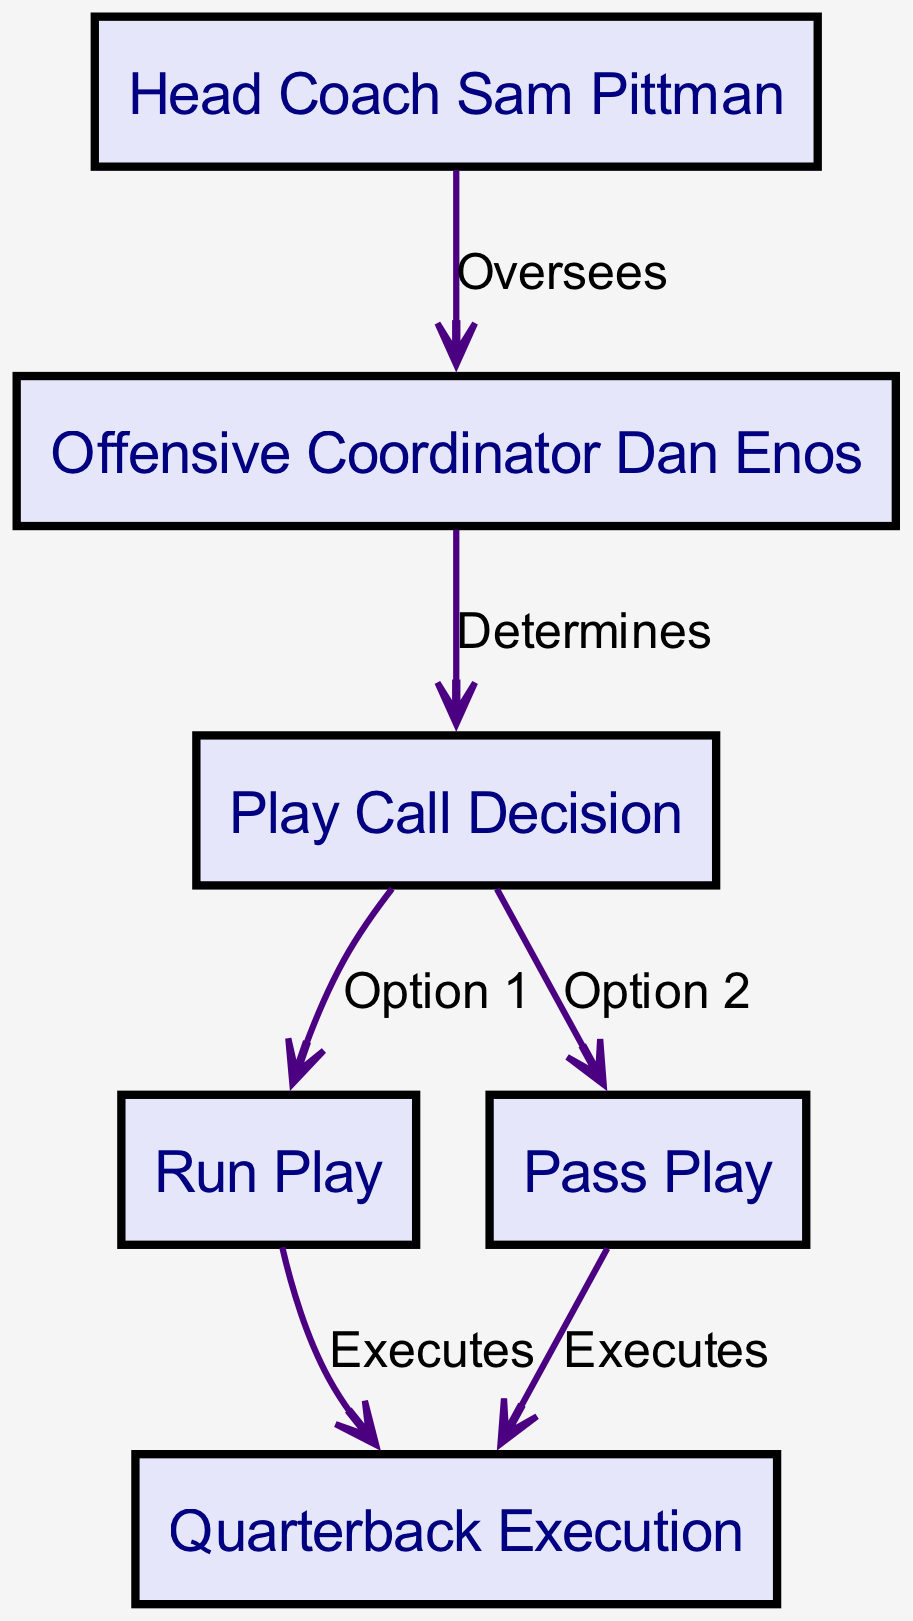What is the name of the head coach? The head coach is identified in the diagram as "Head Coach Sam Pittman." This can be found at the top of the block diagram.
Answer: Head Coach Sam Pittman Who oversees the offensive coordinator? The diagram shows an arrow labeled "Oversees" pointing from the "Head Coach Sam Pittman" to the "Offensive Coordinator Dan Enos." This indicates the supervisory relationship between them.
Answer: Head Coach Sam Pittman What is the first option in the play call decision? The diagram presents "Option 1" from the "Play Call Decision" node leading to the "Run Play" node, indicating that run plays are the first option considered.
Answer: Run Play How many main play options are present in the diagram? From the "Play Call Decision" node, there are two distinct options noted: "Run Play" and "Pass Play." This can be counted directly from the connections branching out from the play call decision node.
Answer: 2 What does the offensive coordinator determine? The diagram indicates that the "Offensive Coordinator Dan Enos" determines the "Play Call Decision," as shown by the edge labeled "Determines" connecting these two nodes.
Answer: Play Call Decision Who executes both the run and pass plays? The diagram shows arrows connecting both the "Run Play" and "Pass Play" to the "Quarterback Execution." This indicates that the quarterback is responsible for executing both types of plays.
Answer: Quarterback Execution What type of relationship exists between head coach and offensive coordinator? The relationship is labeled as "Oversees," indicating a supervisory or managerial connection. This is evident from the directed edge in the diagram.
Answer: Oversees Which role directly impacts the quarterback's execution? The direct impact on the quarterback's execution comes from both the "Run Play" and "Pass Play," as they lead to the "Quarterback Execution." This implies that both play types inform how the quarterback performs.
Answer: Run Play and Pass Play What color represents the nodes in the diagram? The nodes in the block diagram are represented with a filled color of "#E6E6FA," which is a light lavender shade. This is specified in the diagram's node styling attributes.
Answer: Light lavender 